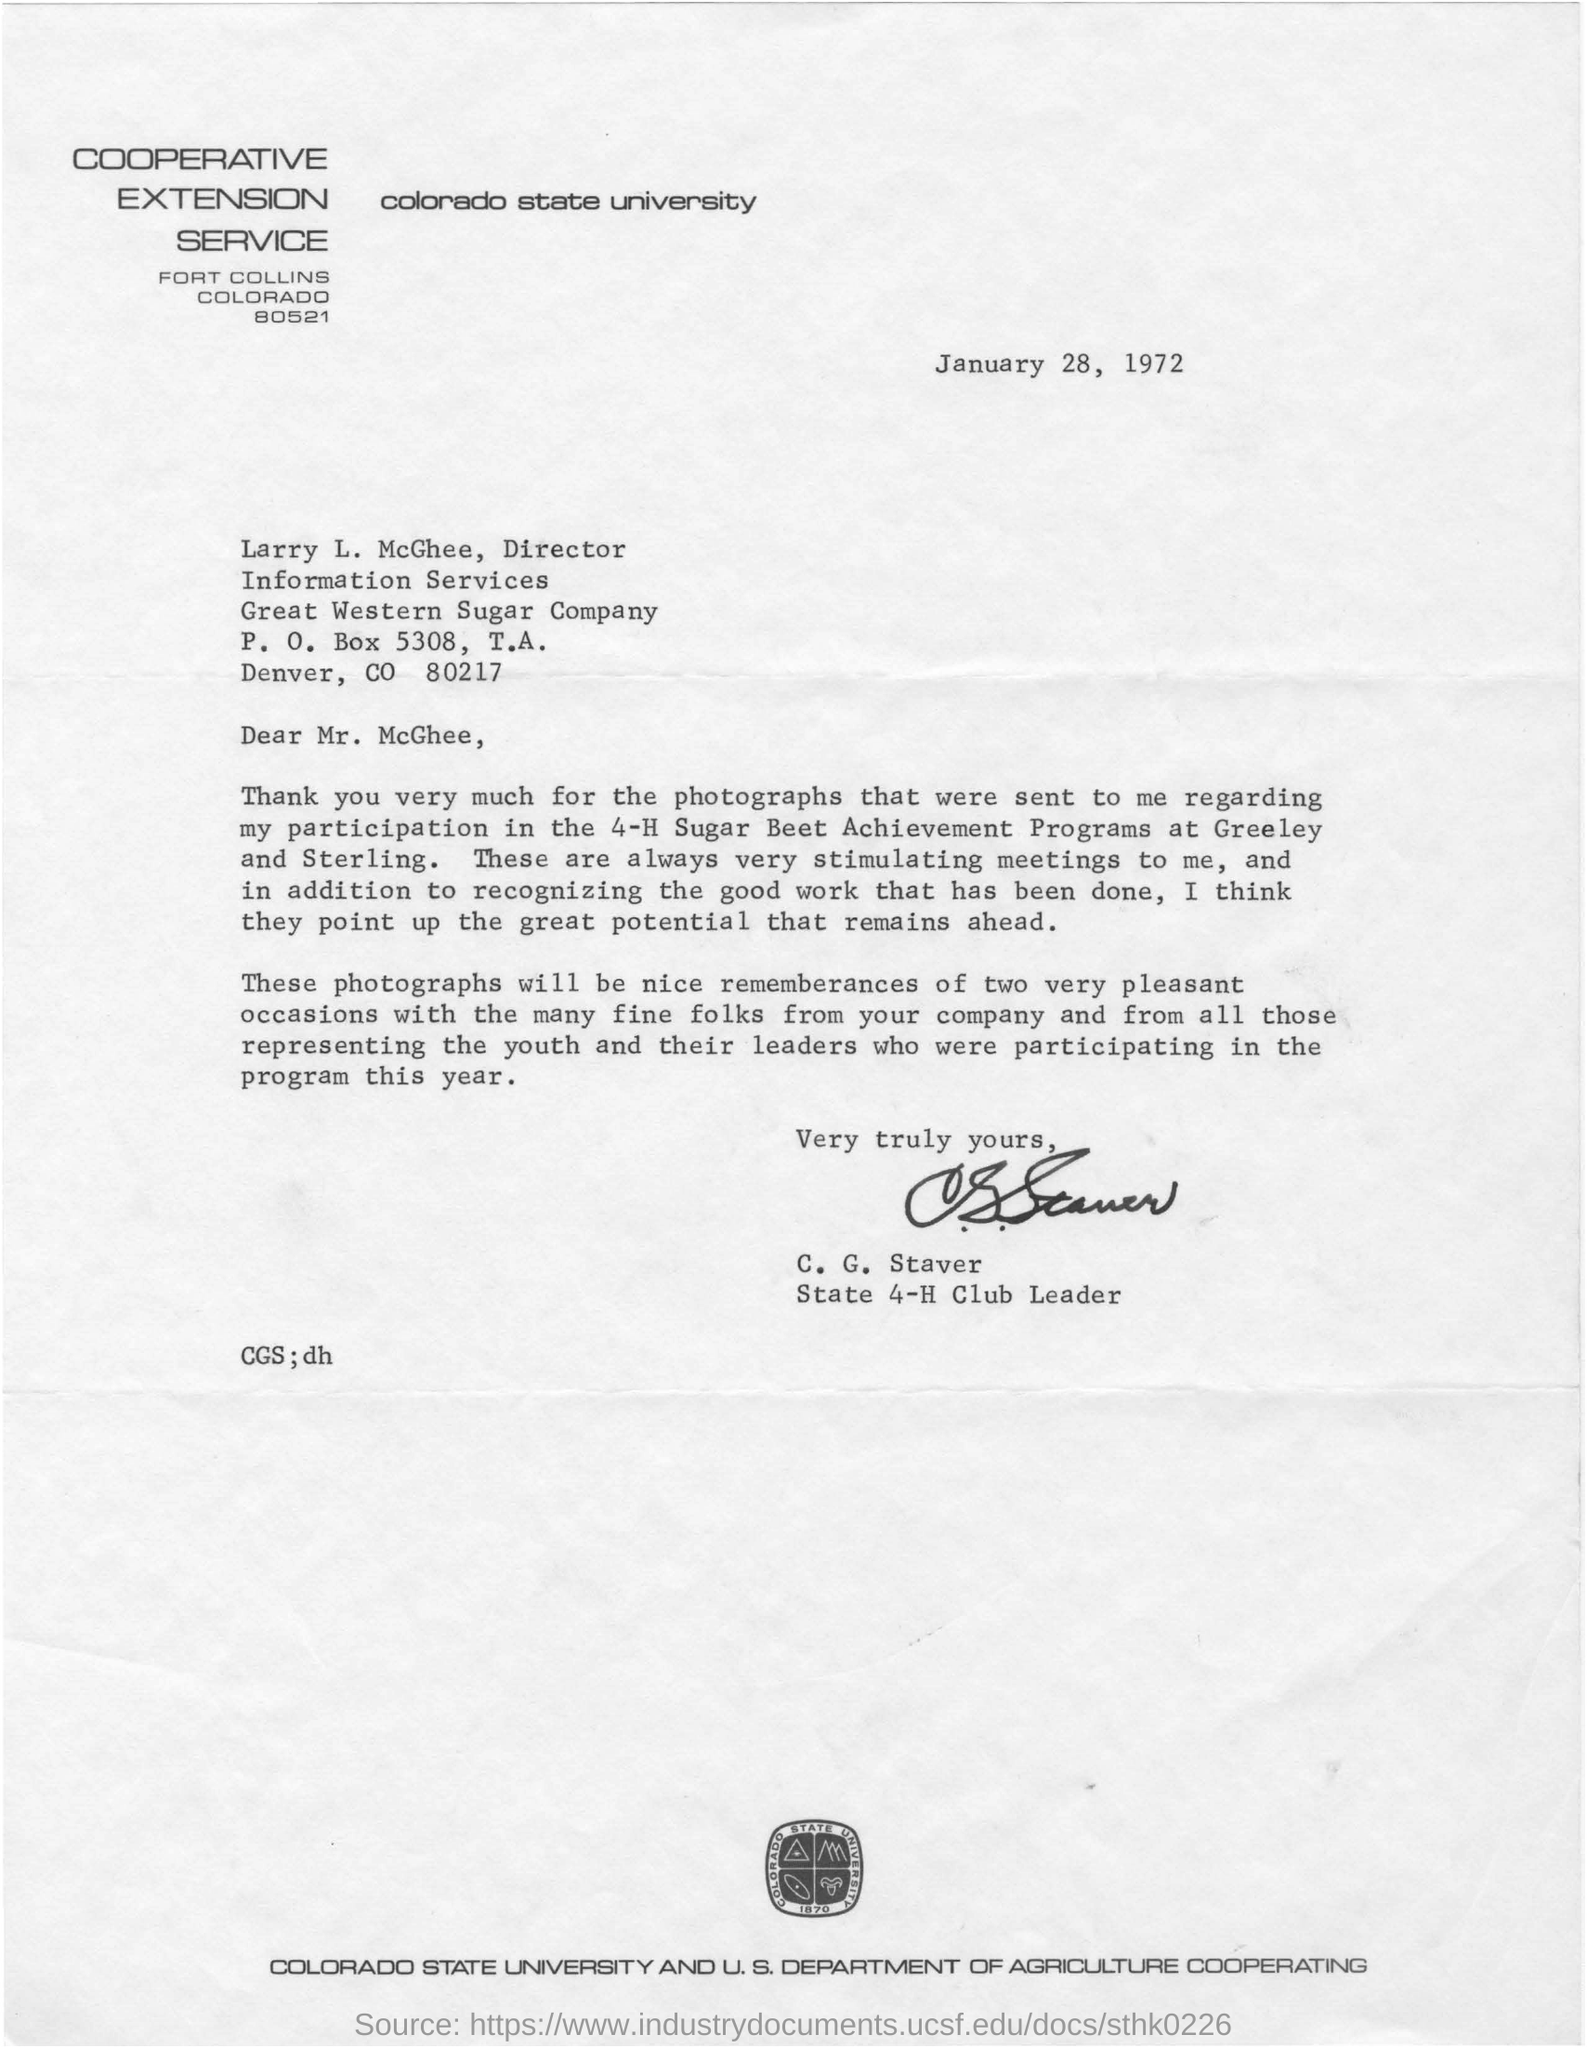Which university is mentioned in the letter head?
Make the answer very short. Colorado state university. Which is the date in the letter?
Ensure brevity in your answer.  January 28, 1972. What is the zip code of the receiver of the letter?
Offer a terse response. CO 80217. Where was the 4-H Sugar Beet Achievement Programs conducted?
Provide a succinct answer. Greeley and Sterling. 